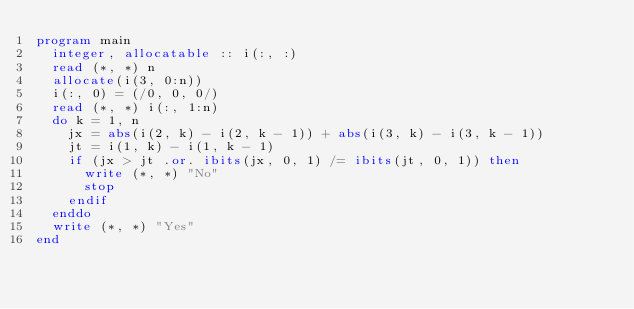Convert code to text. <code><loc_0><loc_0><loc_500><loc_500><_FORTRAN_>program main
  integer, allocatable :: i(:, :)
  read (*, *) n
  allocate(i(3, 0:n))
  i(:, 0) = (/0, 0, 0/)
  read (*, *) i(:, 1:n)
  do k = 1, n
    jx = abs(i(2, k) - i(2, k - 1)) + abs(i(3, k) - i(3, k - 1))
    jt = i(1, k) - i(1, k - 1)
    if (jx > jt .or. ibits(jx, 0, 1) /= ibits(jt, 0, 1)) then
      write (*, *) "No"
      stop
    endif
  enddo
  write (*, *) "Yes"
end
</code> 